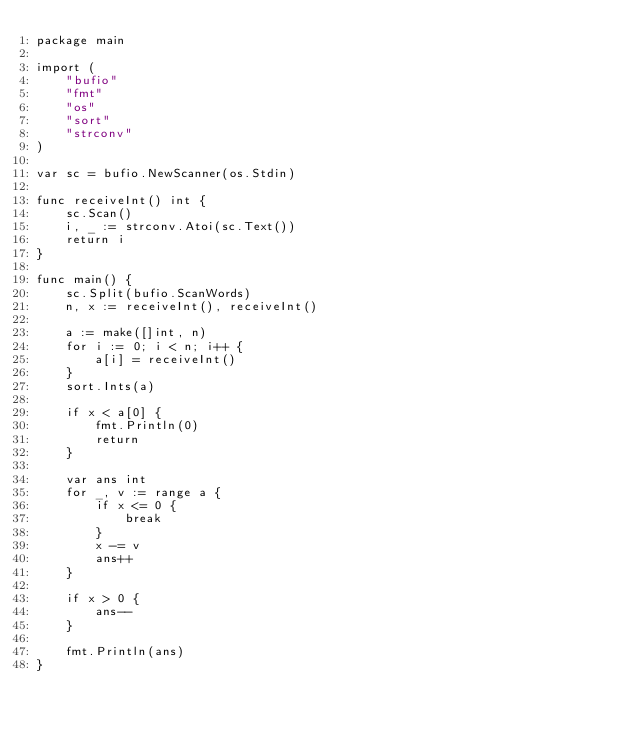<code> <loc_0><loc_0><loc_500><loc_500><_Go_>package main

import (
	"bufio"
	"fmt"
	"os"
	"sort"
	"strconv"
)

var sc = bufio.NewScanner(os.Stdin)

func receiveInt() int {
	sc.Scan()
	i, _ := strconv.Atoi(sc.Text())
	return i
}

func main() {
	sc.Split(bufio.ScanWords)
	n, x := receiveInt(), receiveInt()

	a := make([]int, n)
	for i := 0; i < n; i++ {
		a[i] = receiveInt()
	}
	sort.Ints(a)

	if x < a[0] {
		fmt.Println(0)
		return
	}

	var ans int
	for _, v := range a {
		if x <= 0 {
			break
		}
		x -= v
		ans++
	}

	if x > 0 {
		ans--
	}

	fmt.Println(ans)
}
</code> 